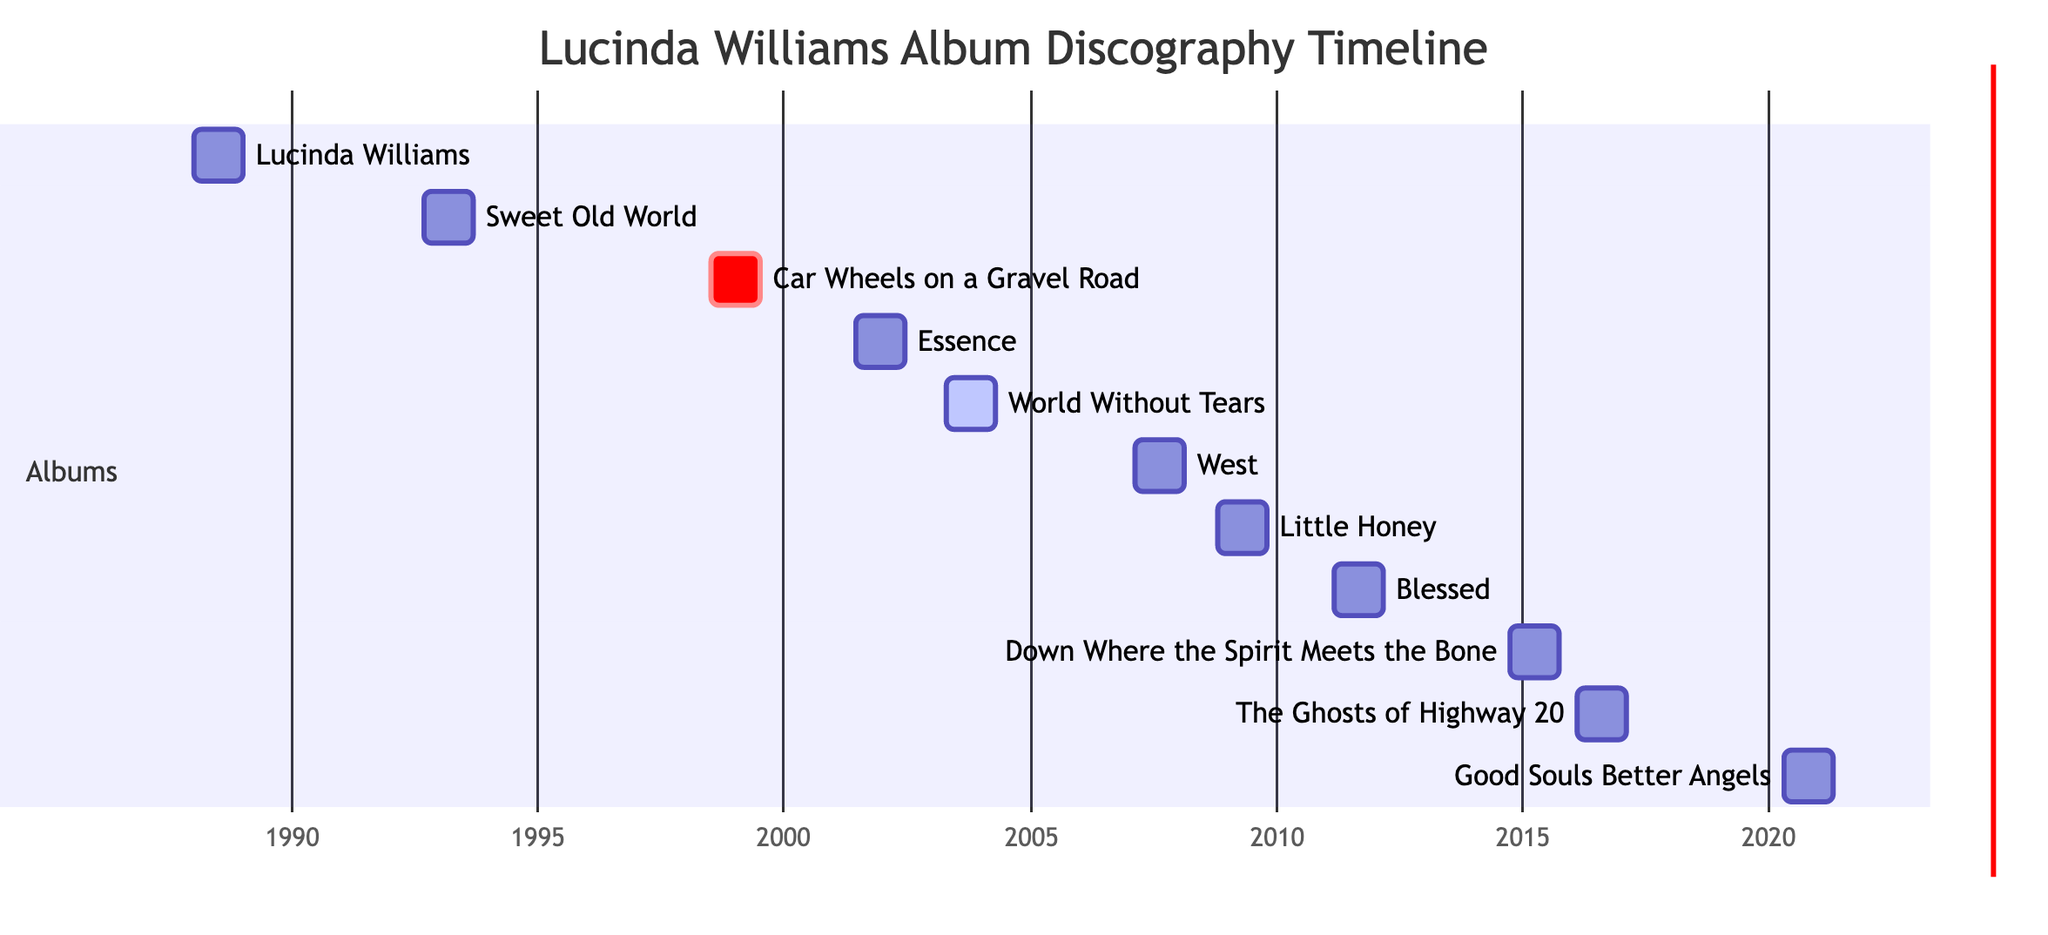What is the title of Lucinda Williams' first album? The diagram shows a list of albums with their release dates. The first album listed is "Lucinda Williams," which was released on January 1, 1988.
Answer: Lucinda Williams In what year was "Blessed" released? Looking at the diagram, the album "Blessed" is listed with a release date of March 1, 2011. Therefore, the year of release is 2011.
Answer: 2011 Which album is marked as a breakthrough album? The diagram includes a note next to the album "Car Wheels on a Gravel Road" stating it is a breakthrough album. This can be identified by the "crit" label next to it.
Answer: Car Wheels on a Gravel Road How many albums were released between 2000 and 2010? By analyzing the diagram, the albums released in that period are "Essence" in 2001, "World Without Tears" in 2003, "West" in 2007, and "Little Honey" in 2008, totaling four albums.
Answer: 4 Which album was released most recently? The diagram indicates the last album listed is "Good Souls Better Angels," released on April 24, 2020, making it the most recent album in the timeline.
Answer: Good Souls Better Angels What is the duration of "Sweet Old World"? Each album in the diagram lists its duration. "Sweet Old World" has a duration of "1 year."
Answer: 1 year Which two albums were released in the same year? Analyzing the timeline, the albums "Little Honey" and "Blessed" were released in consecutive years but not the same year. Therefore, there are no albums released in the same year.
Answer: None What is the significance of the album "World Without Tears"? The diagram notes that "World Without Tears" includes a point of interest, mentioning that it includes the song "Righteously" which hit the radio, indicating its importance in Lucinda Williams' discography.
Answer: Righteously hit the radio How many albums did Lucinda Williams release in the 1990s? The albums released in the 1990s as indicated in the timeline are "Lucinda Williams" (1988), "Sweet Old World" (1992), and "Car Wheels on a Gravel Road" (1998), which totals three albums.
Answer: 3 